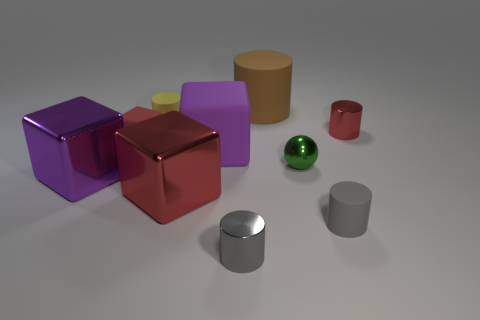Subtract 1 cylinders. How many cylinders are left? 4 Subtract all large cylinders. How many cylinders are left? 4 Subtract all yellow cylinders. How many cylinders are left? 4 Subtract all purple cylinders. Subtract all red spheres. How many cylinders are left? 5 Subtract all cubes. How many objects are left? 6 Add 2 red blocks. How many red blocks exist? 4 Subtract 0 gray blocks. How many objects are left? 10 Subtract all tiny spheres. Subtract all spheres. How many objects are left? 8 Add 7 large brown things. How many large brown things are left? 8 